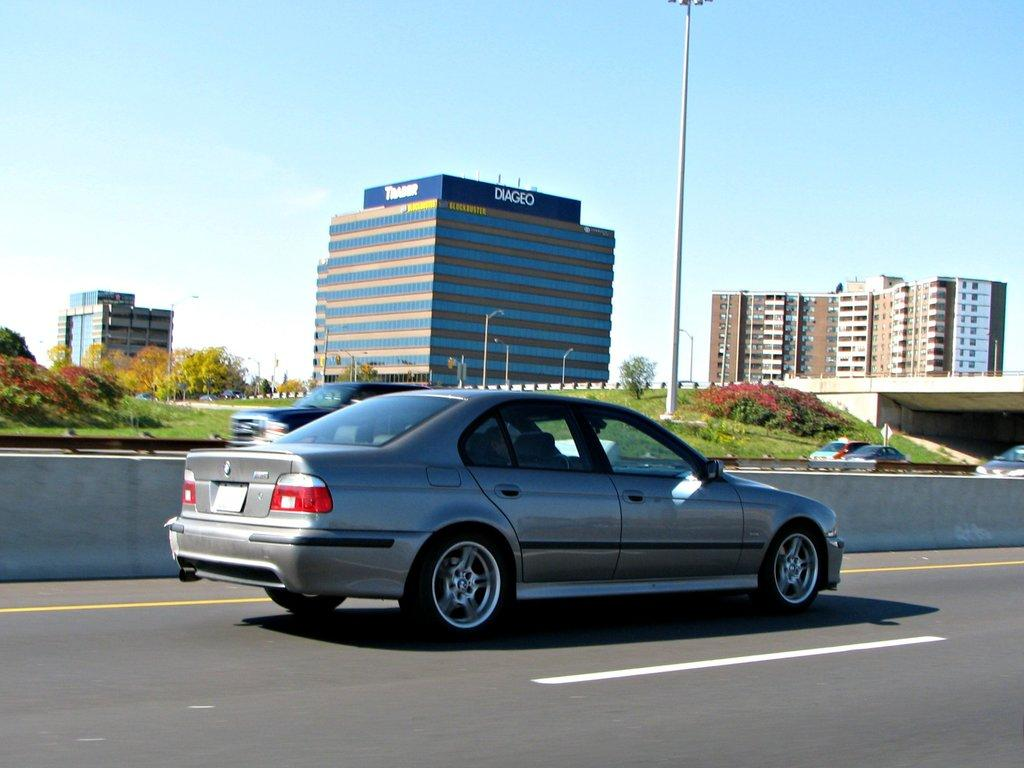What can be seen on the road in the image? There are cars on the road in the image. What is attached to the wall in the image? There is a rod attached to the wall in the image. What type of vegetation is visible in the background of the image? There are plants and trees in the background of the image. What type of artificial lighting is present in the background of the image? There are street lights in the background of the image. What type of structure is visible in the background of the image? There is a bridge in the background of the image. What type of man-made structures are visible in the background of the image? There are buildings in the background of the image. What part of the natural environment is visible in the background of the image? The sky is visible in the background of the image. How many slaves are visible in the image? There are no slaves present in the image. What type of tool is being used to hammer the bridge in the image? There is no hammer or any construction activity depicted in the image; it only shows cars on the road, a wall with a rod, plants and trees, street lights, a bridge, buildings, and the sky. 